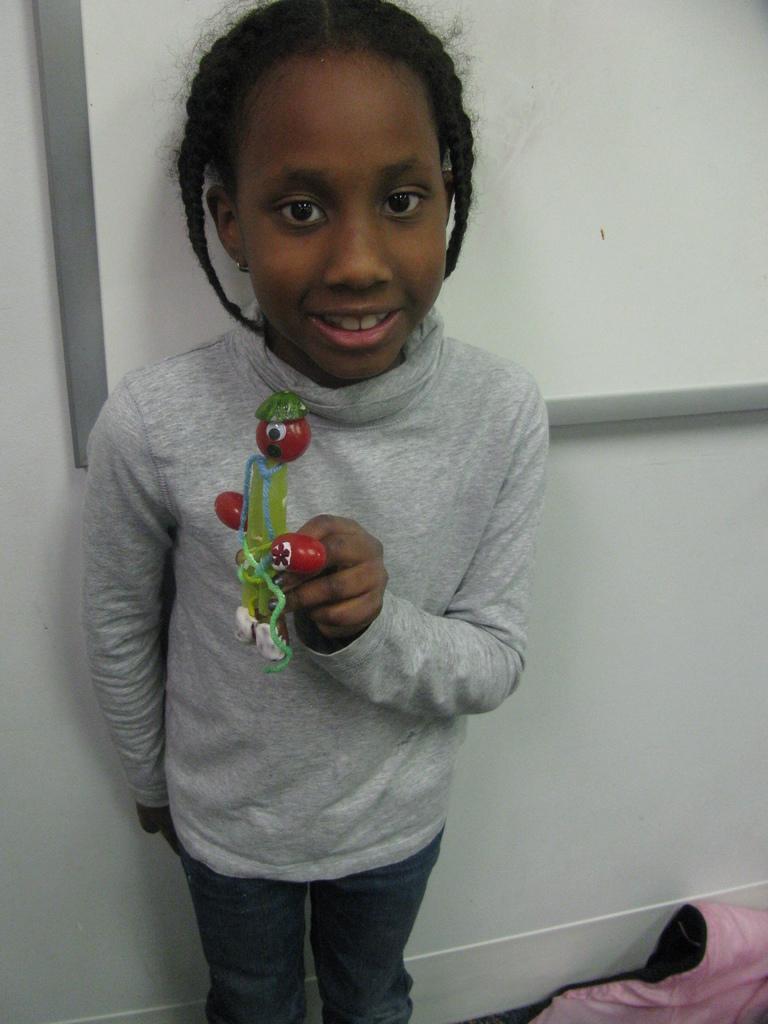Could you give a brief overview of what you see in this image? In the center of the picture there is a girl holding a toy. On the right there is a cloth. At the top it is board. In the center it is wall painted white. 